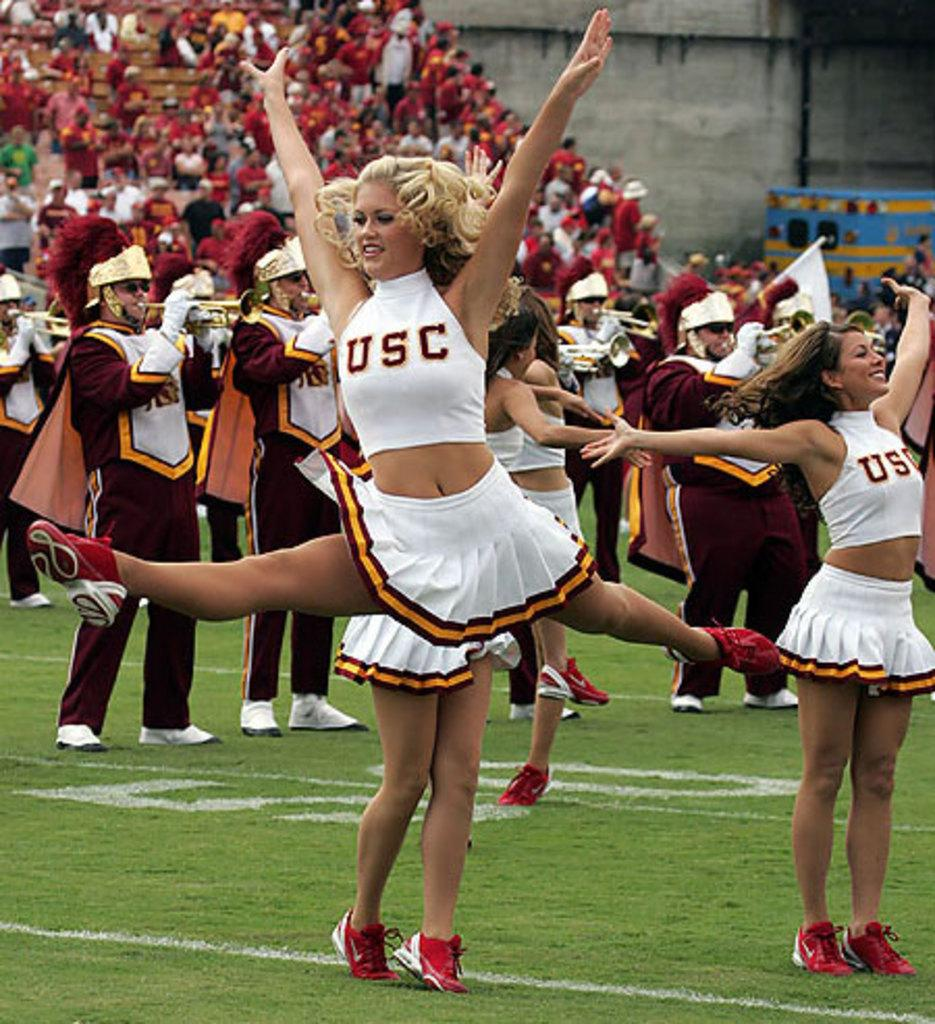<image>
Provide a brief description of the given image. A USC cheerleader does the splits in mid air as the band plays behind her. 